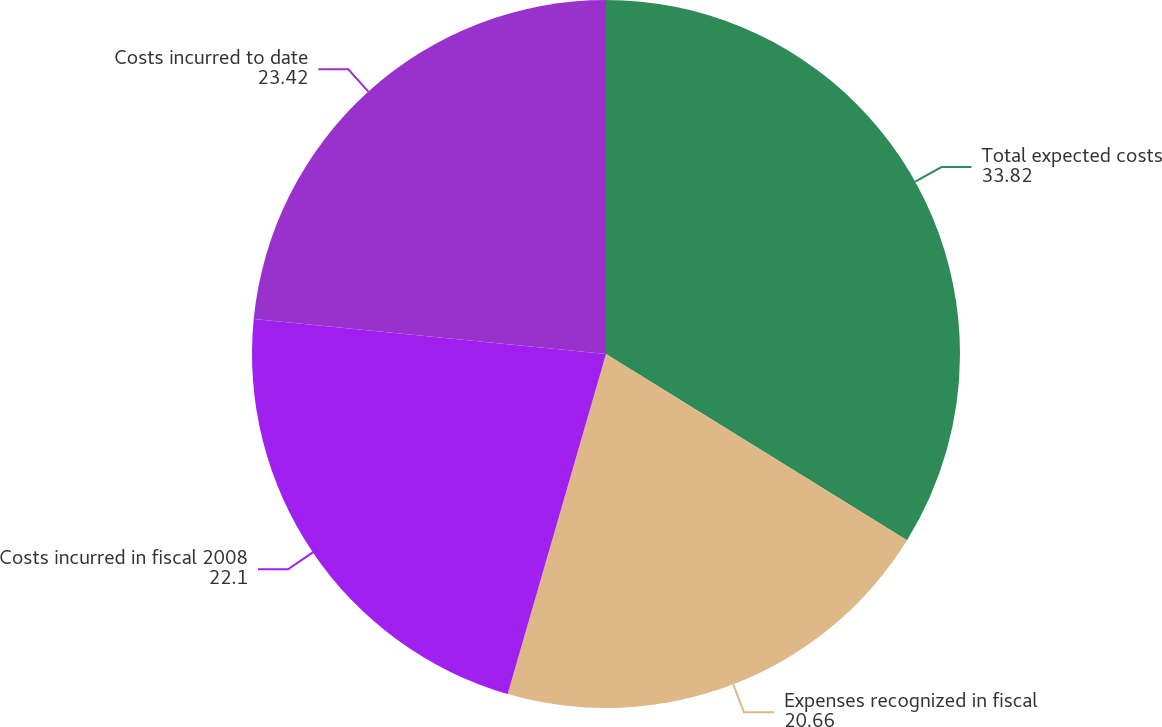Convert chart. <chart><loc_0><loc_0><loc_500><loc_500><pie_chart><fcel>Total expected costs<fcel>Expenses recognized in fiscal<fcel>Costs incurred in fiscal 2008<fcel>Costs incurred to date<nl><fcel>33.82%<fcel>20.66%<fcel>22.1%<fcel>23.42%<nl></chart> 